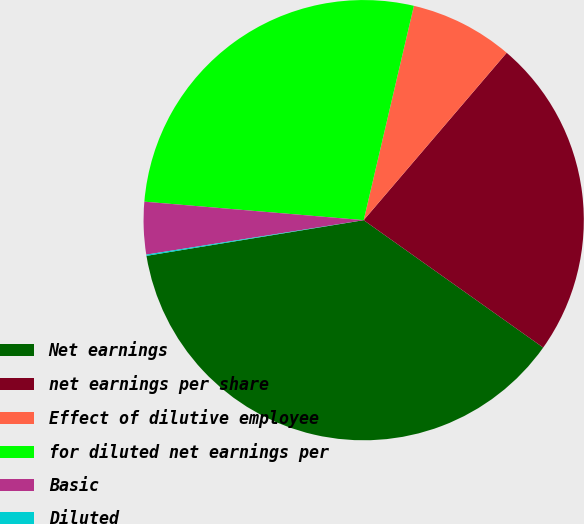Convert chart to OTSL. <chart><loc_0><loc_0><loc_500><loc_500><pie_chart><fcel>Net earnings<fcel>net earnings per share<fcel>Effect of dilutive employee<fcel>for diluted net earnings per<fcel>Basic<fcel>Diluted<nl><fcel>37.58%<fcel>23.57%<fcel>7.59%<fcel>27.32%<fcel>3.84%<fcel>0.09%<nl></chart> 